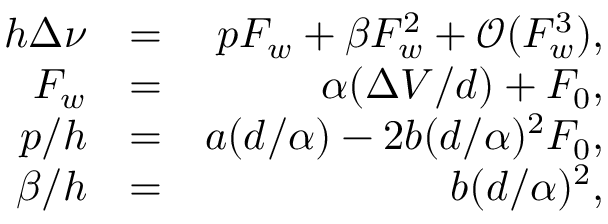<formula> <loc_0><loc_0><loc_500><loc_500>\begin{array} { r l r } { h \Delta \nu } & { = } & { p F _ { w } + \beta F _ { w } ^ { 2 } + \mathcal { O } ( F _ { w } ^ { 3 } ) , } \\ { F _ { w } } & { = } & { \alpha ( \Delta V / d ) + F _ { 0 } , } \\ { p / h } & { = } & { a ( d / \alpha ) - 2 b ( d / \alpha ) ^ { 2 } F _ { 0 } , } \\ { \beta / h } & { = } & { b ( d / \alpha ) ^ { 2 } , } \end{array}</formula> 